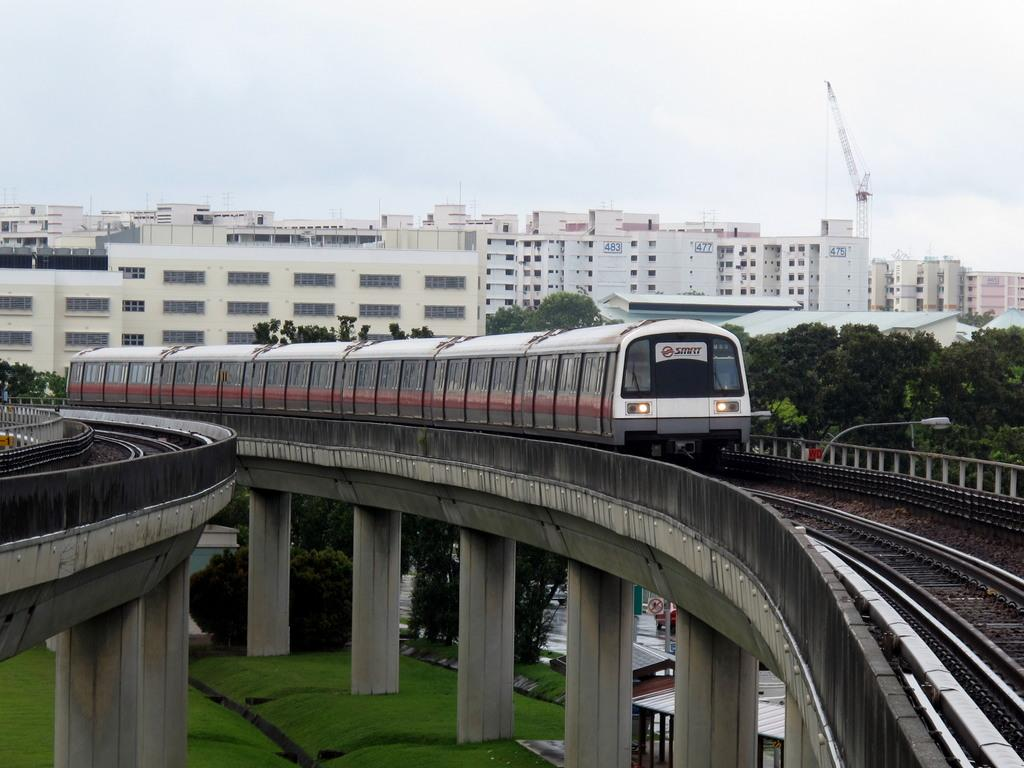What is the main subject of the image? The main subject of the image is a train on the tracks. What can be seen in the background of the image? There are trees and a building visible in the image. What supports the train tracks in the image? There are pillars under the tracks in the image. How many lawyers are present in the image? There are no lawyers present in the image. What type of string can be seen connecting the trees in the image? There is no string connecting the trees in the image. 